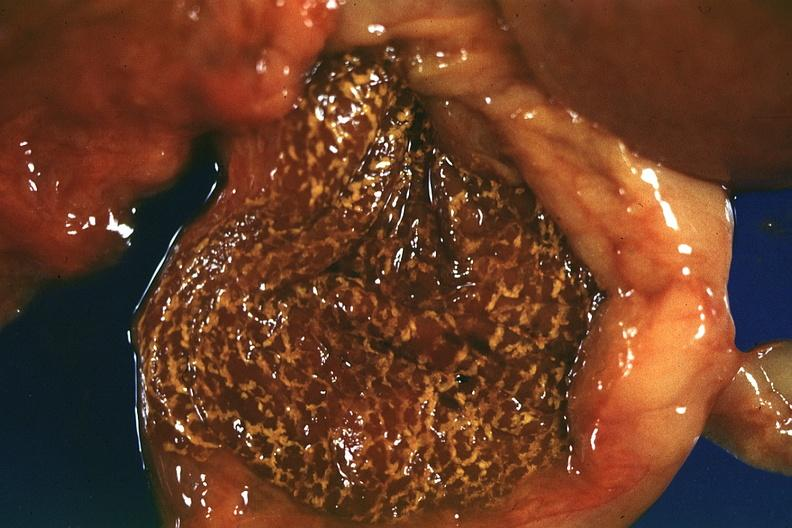does placenta show fresh tissue but rather autolyzed appearance?
Answer the question using a single word or phrase. No 